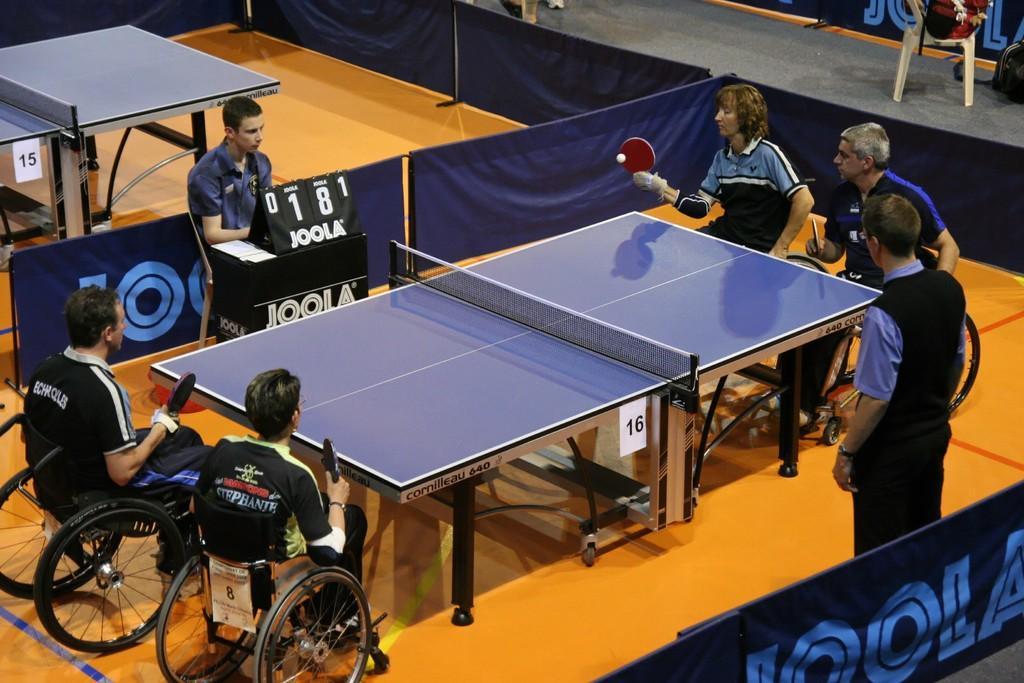Can you describe this image briefly? In this image, There is a floor which is in orange color, There is a table which is in blue color, There are some people sitting on the wheel chairs, In the middle there is a man sitting behind a black color box. 